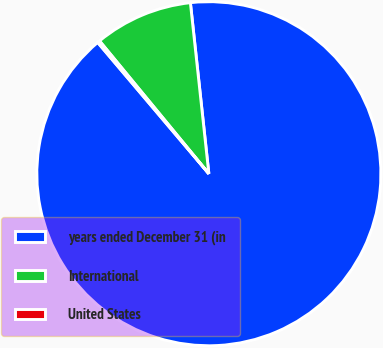Convert chart to OTSL. <chart><loc_0><loc_0><loc_500><loc_500><pie_chart><fcel>years ended December 31 (in<fcel>International<fcel>United States<nl><fcel>90.52%<fcel>9.25%<fcel>0.22%<nl></chart> 